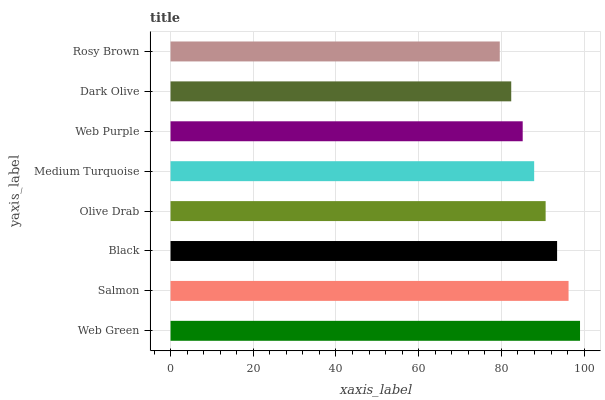Is Rosy Brown the minimum?
Answer yes or no. Yes. Is Web Green the maximum?
Answer yes or no. Yes. Is Salmon the minimum?
Answer yes or no. No. Is Salmon the maximum?
Answer yes or no. No. Is Web Green greater than Salmon?
Answer yes or no. Yes. Is Salmon less than Web Green?
Answer yes or no. Yes. Is Salmon greater than Web Green?
Answer yes or no. No. Is Web Green less than Salmon?
Answer yes or no. No. Is Olive Drab the high median?
Answer yes or no. Yes. Is Medium Turquoise the low median?
Answer yes or no. Yes. Is Dark Olive the high median?
Answer yes or no. No. Is Black the low median?
Answer yes or no. No. 